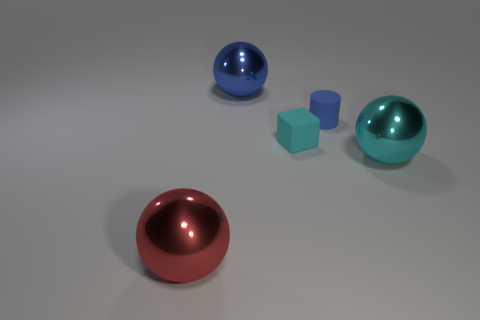What number of objects are the same color as the tiny block?
Give a very brief answer. 1. There is a metal thing to the right of the large blue object; is its color the same as the cube?
Keep it short and to the point. Yes. What is the size of the blue thing in front of the ball that is behind the cyan sphere?
Offer a terse response. Small. There is a large ball that is in front of the small matte cylinder and on the left side of the matte cube; what is its color?
Provide a short and direct response. Red. There is a cyan object that is the same size as the red shiny thing; what is its material?
Offer a terse response. Metal. What number of other things are there of the same material as the tiny blue cylinder
Provide a short and direct response. 1. There is a shiny thing that is to the right of the big blue metallic thing; is its color the same as the matte object on the left side of the tiny blue matte cylinder?
Provide a short and direct response. Yes. There is a large blue shiny thing behind the cyan thing to the left of the blue matte cylinder; what is its shape?
Offer a very short reply. Sphere. How many other objects are there of the same color as the matte cylinder?
Your answer should be very brief. 1. Are the large thing behind the cyan block and the cyan thing that is on the right side of the cyan cube made of the same material?
Your response must be concise. Yes. 